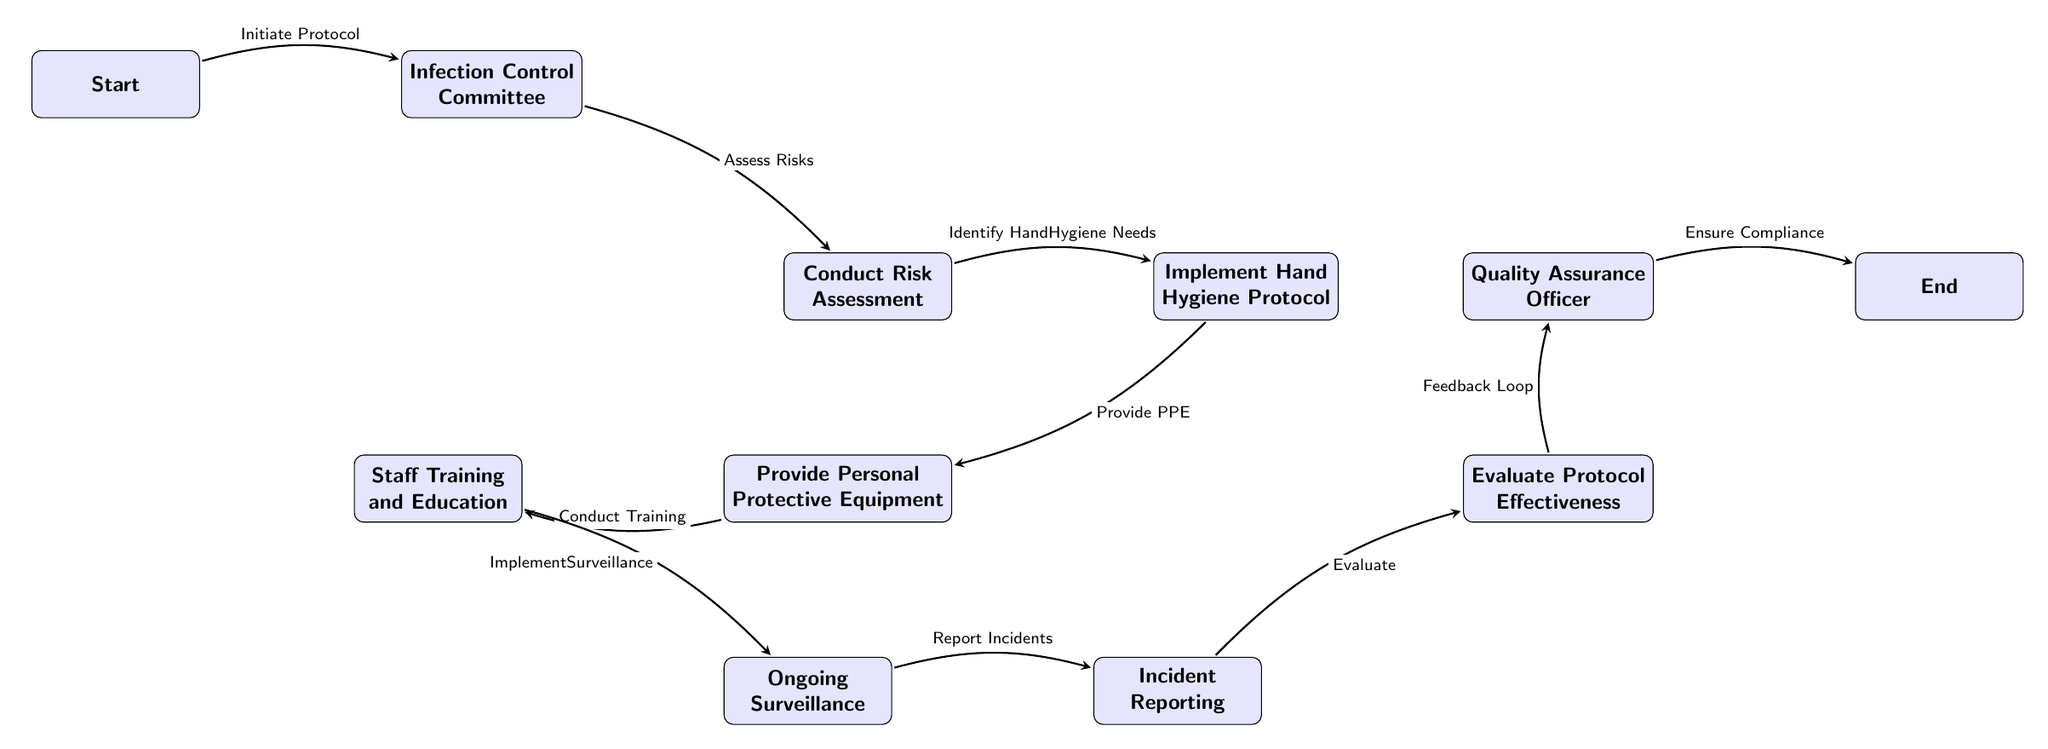What is the first step in the protocol? The first step in the diagram is represented by the node labeled "Start". From this node, the flow initiates toward the Infection Control Committee, indicating it is the first action taken.
Answer: Start How many main nodes are there in the diagram? By counting each distinct node in the flow, there are a total of nine main nodes: Start, Infection Control Committee, Conduct Risk Assessment, Implement Hand Hygiene Protocol, Provide Personal Protective Equipment, Staff Training and Education, Ongoing Surveillance, Incident Reporting, Evaluate Protocol Effectiveness, Quality Assurance Officer, and End.
Answer: Eleven What follows the Implementation of Hand Hygiene Protocol? After "Implement Hand Hygiene Protocol", the next node in the flow is "Provide Personal Protective Equipment". This indicates the direct sequential relationship in the protocol.
Answer: Provide Personal Protective Equipment Who is responsible for ensuring compliance at the end of the protocol? The last node before reaching the end of the flow is "Quality Assurance Officer". This designation implies the responsibility for ensuring that all procedures are followed correctly before concluding the protocol.
Answer: Quality Assurance Officer What action is taken just before the Evaluation of Protocol Effectiveness? Before the "Evaluate Protocol Effectiveness" node, the previous step is "Incident Reporting". This means that incidents must be reported for evaluation to take place.
Answer: Incident Reporting What is the purpose of the Ongoing Surveillance step? The "Ongoing Surveillance" step in the diagram serves to implement a system for continuous monitoring of infection control procedures, ensuring adherence and identifying areas for improvement.
Answer: Continuous monitoring What is indicated by the Feedback Loop arrow? The "Feedback Loop" arrow from "Evaluate Protocol Effectiveness" to "Quality Assurance Officer" indicates a cyclical process where the evaluation results inform future compliance and improvements in the infection control protocol.
Answer: Improvement process Which step directly follows the risk assessment? Following the "Conduct Risk Assessment", the next step is "Implement Hand Hygiene Protocol" as shown in the sequential flow of processes in the diagram.
Answer: Implement Hand Hygiene Protocol 